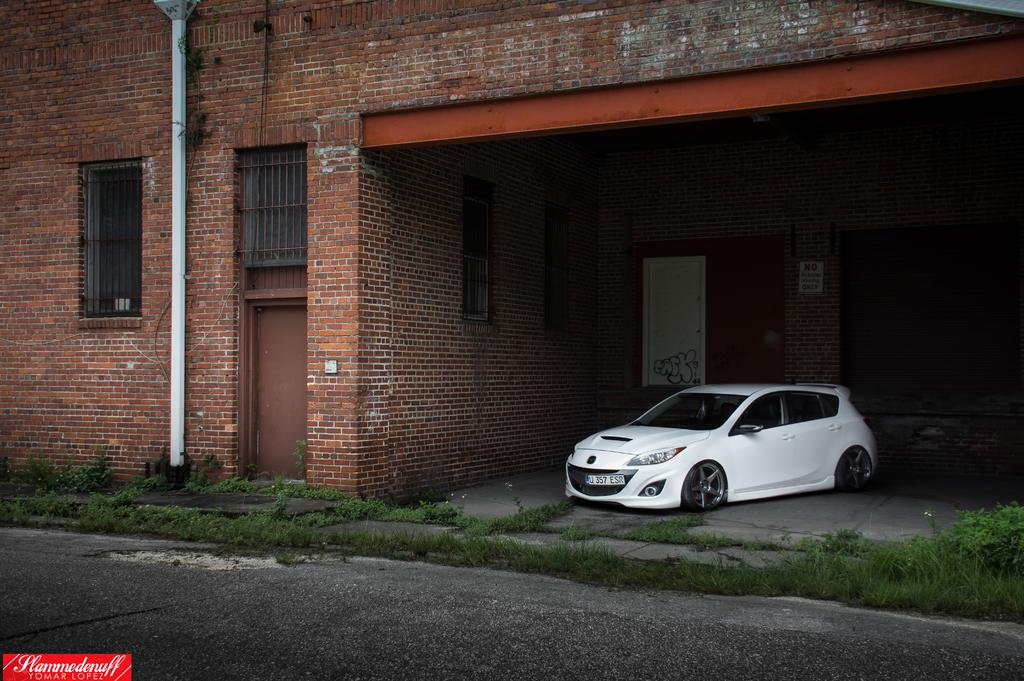What type of vehicle is on the ground in the image? There is a white car on the ground in the image. What type of structure can be seen in the image? There is a building in the image. What architectural feature is present in the image? There is a window, a door, and a wall in the image. What is the surface on which the car is parked? There is a road in the image. What type of vegetation is visible in the image? There is grass in the image. Can you point out the trail of breadcrumbs leading to the car in the image? There is no trail of breadcrumbs present in the image. 